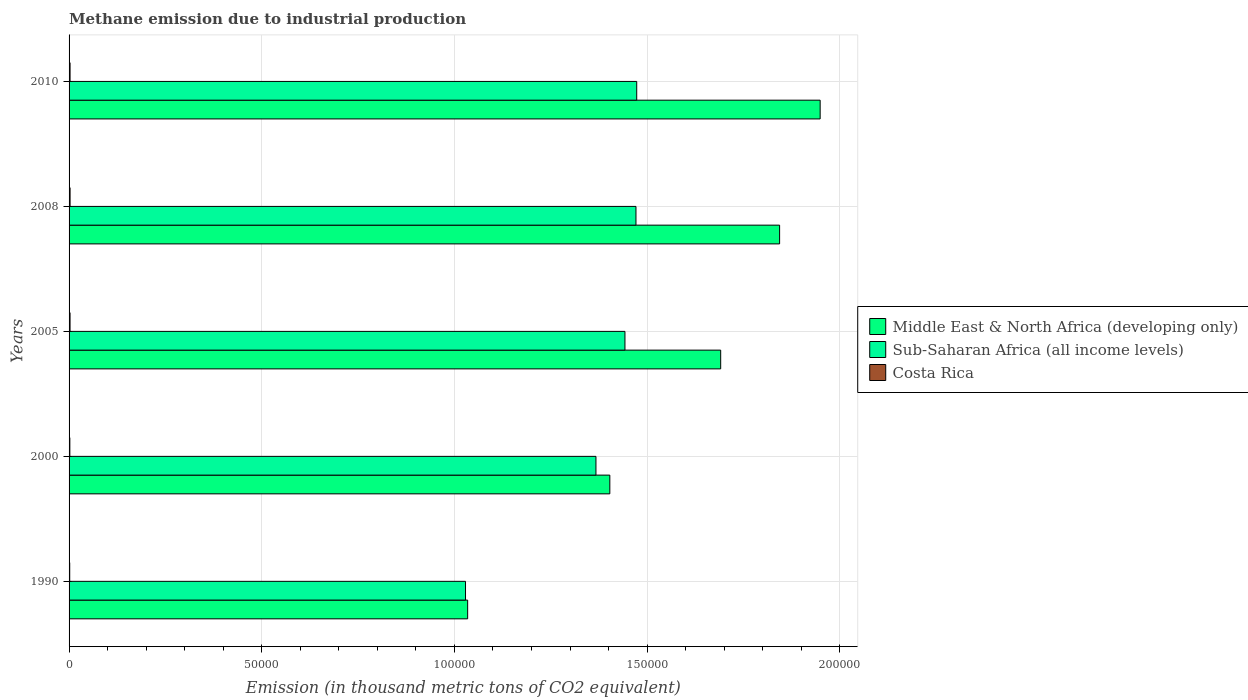How many different coloured bars are there?
Offer a very short reply. 3. Are the number of bars per tick equal to the number of legend labels?
Provide a succinct answer. Yes. Are the number of bars on each tick of the Y-axis equal?
Ensure brevity in your answer.  Yes. How many bars are there on the 2nd tick from the top?
Provide a short and direct response. 3. What is the label of the 1st group of bars from the top?
Give a very brief answer. 2010. In how many cases, is the number of bars for a given year not equal to the number of legend labels?
Your answer should be very brief. 0. What is the amount of methane emitted in Costa Rica in 2008?
Give a very brief answer. 261.8. Across all years, what is the maximum amount of methane emitted in Sub-Saharan Africa (all income levels)?
Offer a terse response. 1.47e+05. Across all years, what is the minimum amount of methane emitted in Sub-Saharan Africa (all income levels)?
Provide a short and direct response. 1.03e+05. In which year was the amount of methane emitted in Costa Rica maximum?
Your answer should be very brief. 2008. In which year was the amount of methane emitted in Middle East & North Africa (developing only) minimum?
Provide a succinct answer. 1990. What is the total amount of methane emitted in Sub-Saharan Africa (all income levels) in the graph?
Provide a succinct answer. 6.78e+05. What is the difference between the amount of methane emitted in Middle East & North Africa (developing only) in 2005 and that in 2010?
Your answer should be very brief. -2.58e+04. What is the difference between the amount of methane emitted in Costa Rica in 2010 and the amount of methane emitted in Middle East & North Africa (developing only) in 2000?
Your response must be concise. -1.40e+05. What is the average amount of methane emitted in Costa Rica per year?
Provide a short and direct response. 229.22. In the year 2008, what is the difference between the amount of methane emitted in Costa Rica and amount of methane emitted in Middle East & North Africa (developing only)?
Make the answer very short. -1.84e+05. In how many years, is the amount of methane emitted in Middle East & North Africa (developing only) greater than 80000 thousand metric tons?
Your answer should be compact. 5. What is the ratio of the amount of methane emitted in Sub-Saharan Africa (all income levels) in 1990 to that in 2005?
Provide a short and direct response. 0.71. Is the difference between the amount of methane emitted in Costa Rica in 1990 and 2010 greater than the difference between the amount of methane emitted in Middle East & North Africa (developing only) in 1990 and 2010?
Ensure brevity in your answer.  Yes. What is the difference between the highest and the second highest amount of methane emitted in Sub-Saharan Africa (all income levels)?
Provide a short and direct response. 192.3. What is the difference between the highest and the lowest amount of methane emitted in Costa Rica?
Offer a terse response. 93.6. In how many years, is the amount of methane emitted in Sub-Saharan Africa (all income levels) greater than the average amount of methane emitted in Sub-Saharan Africa (all income levels) taken over all years?
Offer a very short reply. 4. What does the 2nd bar from the top in 1990 represents?
Offer a terse response. Sub-Saharan Africa (all income levels). What is the difference between two consecutive major ticks on the X-axis?
Your answer should be compact. 5.00e+04. Are the values on the major ticks of X-axis written in scientific E-notation?
Make the answer very short. No. How are the legend labels stacked?
Provide a short and direct response. Vertical. What is the title of the graph?
Offer a terse response. Methane emission due to industrial production. What is the label or title of the X-axis?
Your answer should be very brief. Emission (in thousand metric tons of CO2 equivalent). What is the Emission (in thousand metric tons of CO2 equivalent) of Middle East & North Africa (developing only) in 1990?
Your answer should be compact. 1.03e+05. What is the Emission (in thousand metric tons of CO2 equivalent) in Sub-Saharan Africa (all income levels) in 1990?
Your response must be concise. 1.03e+05. What is the Emission (in thousand metric tons of CO2 equivalent) of Costa Rica in 1990?
Provide a short and direct response. 168.2. What is the Emission (in thousand metric tons of CO2 equivalent) of Middle East & North Africa (developing only) in 2000?
Your answer should be compact. 1.40e+05. What is the Emission (in thousand metric tons of CO2 equivalent) of Sub-Saharan Africa (all income levels) in 2000?
Provide a short and direct response. 1.37e+05. What is the Emission (in thousand metric tons of CO2 equivalent) in Costa Rica in 2000?
Your response must be concise. 202.3. What is the Emission (in thousand metric tons of CO2 equivalent) of Middle East & North Africa (developing only) in 2005?
Offer a terse response. 1.69e+05. What is the Emission (in thousand metric tons of CO2 equivalent) in Sub-Saharan Africa (all income levels) in 2005?
Offer a very short reply. 1.44e+05. What is the Emission (in thousand metric tons of CO2 equivalent) in Costa Rica in 2005?
Your response must be concise. 254.9. What is the Emission (in thousand metric tons of CO2 equivalent) in Middle East & North Africa (developing only) in 2008?
Offer a very short reply. 1.84e+05. What is the Emission (in thousand metric tons of CO2 equivalent) of Sub-Saharan Africa (all income levels) in 2008?
Keep it short and to the point. 1.47e+05. What is the Emission (in thousand metric tons of CO2 equivalent) of Costa Rica in 2008?
Ensure brevity in your answer.  261.8. What is the Emission (in thousand metric tons of CO2 equivalent) in Middle East & North Africa (developing only) in 2010?
Offer a very short reply. 1.95e+05. What is the Emission (in thousand metric tons of CO2 equivalent) in Sub-Saharan Africa (all income levels) in 2010?
Give a very brief answer. 1.47e+05. What is the Emission (in thousand metric tons of CO2 equivalent) in Costa Rica in 2010?
Offer a very short reply. 258.9. Across all years, what is the maximum Emission (in thousand metric tons of CO2 equivalent) in Middle East & North Africa (developing only)?
Your response must be concise. 1.95e+05. Across all years, what is the maximum Emission (in thousand metric tons of CO2 equivalent) in Sub-Saharan Africa (all income levels)?
Ensure brevity in your answer.  1.47e+05. Across all years, what is the maximum Emission (in thousand metric tons of CO2 equivalent) of Costa Rica?
Your answer should be very brief. 261.8. Across all years, what is the minimum Emission (in thousand metric tons of CO2 equivalent) of Middle East & North Africa (developing only)?
Provide a succinct answer. 1.03e+05. Across all years, what is the minimum Emission (in thousand metric tons of CO2 equivalent) of Sub-Saharan Africa (all income levels)?
Provide a short and direct response. 1.03e+05. Across all years, what is the minimum Emission (in thousand metric tons of CO2 equivalent) of Costa Rica?
Offer a very short reply. 168.2. What is the total Emission (in thousand metric tons of CO2 equivalent) of Middle East & North Africa (developing only) in the graph?
Provide a short and direct response. 7.92e+05. What is the total Emission (in thousand metric tons of CO2 equivalent) in Sub-Saharan Africa (all income levels) in the graph?
Your answer should be compact. 6.78e+05. What is the total Emission (in thousand metric tons of CO2 equivalent) in Costa Rica in the graph?
Your response must be concise. 1146.1. What is the difference between the Emission (in thousand metric tons of CO2 equivalent) of Middle East & North Africa (developing only) in 1990 and that in 2000?
Keep it short and to the point. -3.69e+04. What is the difference between the Emission (in thousand metric tons of CO2 equivalent) in Sub-Saharan Africa (all income levels) in 1990 and that in 2000?
Make the answer very short. -3.38e+04. What is the difference between the Emission (in thousand metric tons of CO2 equivalent) of Costa Rica in 1990 and that in 2000?
Provide a short and direct response. -34.1. What is the difference between the Emission (in thousand metric tons of CO2 equivalent) of Middle East & North Africa (developing only) in 1990 and that in 2005?
Ensure brevity in your answer.  -6.57e+04. What is the difference between the Emission (in thousand metric tons of CO2 equivalent) in Sub-Saharan Africa (all income levels) in 1990 and that in 2005?
Keep it short and to the point. -4.14e+04. What is the difference between the Emission (in thousand metric tons of CO2 equivalent) in Costa Rica in 1990 and that in 2005?
Make the answer very short. -86.7. What is the difference between the Emission (in thousand metric tons of CO2 equivalent) in Middle East & North Africa (developing only) in 1990 and that in 2008?
Offer a very short reply. -8.10e+04. What is the difference between the Emission (in thousand metric tons of CO2 equivalent) of Sub-Saharan Africa (all income levels) in 1990 and that in 2008?
Your answer should be very brief. -4.42e+04. What is the difference between the Emission (in thousand metric tons of CO2 equivalent) of Costa Rica in 1990 and that in 2008?
Provide a short and direct response. -93.6. What is the difference between the Emission (in thousand metric tons of CO2 equivalent) in Middle East & North Africa (developing only) in 1990 and that in 2010?
Make the answer very short. -9.15e+04. What is the difference between the Emission (in thousand metric tons of CO2 equivalent) of Sub-Saharan Africa (all income levels) in 1990 and that in 2010?
Make the answer very short. -4.44e+04. What is the difference between the Emission (in thousand metric tons of CO2 equivalent) of Costa Rica in 1990 and that in 2010?
Keep it short and to the point. -90.7. What is the difference between the Emission (in thousand metric tons of CO2 equivalent) of Middle East & North Africa (developing only) in 2000 and that in 2005?
Your answer should be compact. -2.88e+04. What is the difference between the Emission (in thousand metric tons of CO2 equivalent) of Sub-Saharan Africa (all income levels) in 2000 and that in 2005?
Keep it short and to the point. -7528.2. What is the difference between the Emission (in thousand metric tons of CO2 equivalent) of Costa Rica in 2000 and that in 2005?
Give a very brief answer. -52.6. What is the difference between the Emission (in thousand metric tons of CO2 equivalent) of Middle East & North Africa (developing only) in 2000 and that in 2008?
Make the answer very short. -4.41e+04. What is the difference between the Emission (in thousand metric tons of CO2 equivalent) in Sub-Saharan Africa (all income levels) in 2000 and that in 2008?
Make the answer very short. -1.04e+04. What is the difference between the Emission (in thousand metric tons of CO2 equivalent) in Costa Rica in 2000 and that in 2008?
Make the answer very short. -59.5. What is the difference between the Emission (in thousand metric tons of CO2 equivalent) of Middle East & North Africa (developing only) in 2000 and that in 2010?
Your response must be concise. -5.46e+04. What is the difference between the Emission (in thousand metric tons of CO2 equivalent) in Sub-Saharan Africa (all income levels) in 2000 and that in 2010?
Provide a short and direct response. -1.06e+04. What is the difference between the Emission (in thousand metric tons of CO2 equivalent) of Costa Rica in 2000 and that in 2010?
Your answer should be very brief. -56.6. What is the difference between the Emission (in thousand metric tons of CO2 equivalent) in Middle East & North Africa (developing only) in 2005 and that in 2008?
Your response must be concise. -1.53e+04. What is the difference between the Emission (in thousand metric tons of CO2 equivalent) of Sub-Saharan Africa (all income levels) in 2005 and that in 2008?
Your response must be concise. -2859.6. What is the difference between the Emission (in thousand metric tons of CO2 equivalent) in Costa Rica in 2005 and that in 2008?
Your answer should be very brief. -6.9. What is the difference between the Emission (in thousand metric tons of CO2 equivalent) in Middle East & North Africa (developing only) in 2005 and that in 2010?
Your response must be concise. -2.58e+04. What is the difference between the Emission (in thousand metric tons of CO2 equivalent) of Sub-Saharan Africa (all income levels) in 2005 and that in 2010?
Provide a short and direct response. -3051.9. What is the difference between the Emission (in thousand metric tons of CO2 equivalent) in Middle East & North Africa (developing only) in 2008 and that in 2010?
Ensure brevity in your answer.  -1.05e+04. What is the difference between the Emission (in thousand metric tons of CO2 equivalent) in Sub-Saharan Africa (all income levels) in 2008 and that in 2010?
Your answer should be very brief. -192.3. What is the difference between the Emission (in thousand metric tons of CO2 equivalent) in Costa Rica in 2008 and that in 2010?
Give a very brief answer. 2.9. What is the difference between the Emission (in thousand metric tons of CO2 equivalent) of Middle East & North Africa (developing only) in 1990 and the Emission (in thousand metric tons of CO2 equivalent) of Sub-Saharan Africa (all income levels) in 2000?
Your answer should be compact. -3.33e+04. What is the difference between the Emission (in thousand metric tons of CO2 equivalent) of Middle East & North Africa (developing only) in 1990 and the Emission (in thousand metric tons of CO2 equivalent) of Costa Rica in 2000?
Provide a short and direct response. 1.03e+05. What is the difference between the Emission (in thousand metric tons of CO2 equivalent) of Sub-Saharan Africa (all income levels) in 1990 and the Emission (in thousand metric tons of CO2 equivalent) of Costa Rica in 2000?
Offer a very short reply. 1.03e+05. What is the difference between the Emission (in thousand metric tons of CO2 equivalent) in Middle East & North Africa (developing only) in 1990 and the Emission (in thousand metric tons of CO2 equivalent) in Sub-Saharan Africa (all income levels) in 2005?
Your response must be concise. -4.08e+04. What is the difference between the Emission (in thousand metric tons of CO2 equivalent) in Middle East & North Africa (developing only) in 1990 and the Emission (in thousand metric tons of CO2 equivalent) in Costa Rica in 2005?
Your response must be concise. 1.03e+05. What is the difference between the Emission (in thousand metric tons of CO2 equivalent) in Sub-Saharan Africa (all income levels) in 1990 and the Emission (in thousand metric tons of CO2 equivalent) in Costa Rica in 2005?
Offer a very short reply. 1.03e+05. What is the difference between the Emission (in thousand metric tons of CO2 equivalent) of Middle East & North Africa (developing only) in 1990 and the Emission (in thousand metric tons of CO2 equivalent) of Sub-Saharan Africa (all income levels) in 2008?
Provide a short and direct response. -4.37e+04. What is the difference between the Emission (in thousand metric tons of CO2 equivalent) of Middle East & North Africa (developing only) in 1990 and the Emission (in thousand metric tons of CO2 equivalent) of Costa Rica in 2008?
Make the answer very short. 1.03e+05. What is the difference between the Emission (in thousand metric tons of CO2 equivalent) in Sub-Saharan Africa (all income levels) in 1990 and the Emission (in thousand metric tons of CO2 equivalent) in Costa Rica in 2008?
Offer a very short reply. 1.03e+05. What is the difference between the Emission (in thousand metric tons of CO2 equivalent) in Middle East & North Africa (developing only) in 1990 and the Emission (in thousand metric tons of CO2 equivalent) in Sub-Saharan Africa (all income levels) in 2010?
Keep it short and to the point. -4.39e+04. What is the difference between the Emission (in thousand metric tons of CO2 equivalent) in Middle East & North Africa (developing only) in 1990 and the Emission (in thousand metric tons of CO2 equivalent) in Costa Rica in 2010?
Give a very brief answer. 1.03e+05. What is the difference between the Emission (in thousand metric tons of CO2 equivalent) in Sub-Saharan Africa (all income levels) in 1990 and the Emission (in thousand metric tons of CO2 equivalent) in Costa Rica in 2010?
Your answer should be very brief. 1.03e+05. What is the difference between the Emission (in thousand metric tons of CO2 equivalent) in Middle East & North Africa (developing only) in 2000 and the Emission (in thousand metric tons of CO2 equivalent) in Sub-Saharan Africa (all income levels) in 2005?
Provide a short and direct response. -3924.8. What is the difference between the Emission (in thousand metric tons of CO2 equivalent) in Middle East & North Africa (developing only) in 2000 and the Emission (in thousand metric tons of CO2 equivalent) in Costa Rica in 2005?
Provide a short and direct response. 1.40e+05. What is the difference between the Emission (in thousand metric tons of CO2 equivalent) of Sub-Saharan Africa (all income levels) in 2000 and the Emission (in thousand metric tons of CO2 equivalent) of Costa Rica in 2005?
Offer a terse response. 1.36e+05. What is the difference between the Emission (in thousand metric tons of CO2 equivalent) of Middle East & North Africa (developing only) in 2000 and the Emission (in thousand metric tons of CO2 equivalent) of Sub-Saharan Africa (all income levels) in 2008?
Provide a succinct answer. -6784.4. What is the difference between the Emission (in thousand metric tons of CO2 equivalent) of Middle East & North Africa (developing only) in 2000 and the Emission (in thousand metric tons of CO2 equivalent) of Costa Rica in 2008?
Ensure brevity in your answer.  1.40e+05. What is the difference between the Emission (in thousand metric tons of CO2 equivalent) of Sub-Saharan Africa (all income levels) in 2000 and the Emission (in thousand metric tons of CO2 equivalent) of Costa Rica in 2008?
Make the answer very short. 1.36e+05. What is the difference between the Emission (in thousand metric tons of CO2 equivalent) of Middle East & North Africa (developing only) in 2000 and the Emission (in thousand metric tons of CO2 equivalent) of Sub-Saharan Africa (all income levels) in 2010?
Provide a short and direct response. -6976.7. What is the difference between the Emission (in thousand metric tons of CO2 equivalent) in Middle East & North Africa (developing only) in 2000 and the Emission (in thousand metric tons of CO2 equivalent) in Costa Rica in 2010?
Your answer should be compact. 1.40e+05. What is the difference between the Emission (in thousand metric tons of CO2 equivalent) in Sub-Saharan Africa (all income levels) in 2000 and the Emission (in thousand metric tons of CO2 equivalent) in Costa Rica in 2010?
Provide a short and direct response. 1.36e+05. What is the difference between the Emission (in thousand metric tons of CO2 equivalent) in Middle East & North Africa (developing only) in 2005 and the Emission (in thousand metric tons of CO2 equivalent) in Sub-Saharan Africa (all income levels) in 2008?
Give a very brief answer. 2.20e+04. What is the difference between the Emission (in thousand metric tons of CO2 equivalent) of Middle East & North Africa (developing only) in 2005 and the Emission (in thousand metric tons of CO2 equivalent) of Costa Rica in 2008?
Your answer should be compact. 1.69e+05. What is the difference between the Emission (in thousand metric tons of CO2 equivalent) in Sub-Saharan Africa (all income levels) in 2005 and the Emission (in thousand metric tons of CO2 equivalent) in Costa Rica in 2008?
Offer a very short reply. 1.44e+05. What is the difference between the Emission (in thousand metric tons of CO2 equivalent) in Middle East & North Africa (developing only) in 2005 and the Emission (in thousand metric tons of CO2 equivalent) in Sub-Saharan Africa (all income levels) in 2010?
Your response must be concise. 2.18e+04. What is the difference between the Emission (in thousand metric tons of CO2 equivalent) of Middle East & North Africa (developing only) in 2005 and the Emission (in thousand metric tons of CO2 equivalent) of Costa Rica in 2010?
Your answer should be compact. 1.69e+05. What is the difference between the Emission (in thousand metric tons of CO2 equivalent) in Sub-Saharan Africa (all income levels) in 2005 and the Emission (in thousand metric tons of CO2 equivalent) in Costa Rica in 2010?
Ensure brevity in your answer.  1.44e+05. What is the difference between the Emission (in thousand metric tons of CO2 equivalent) in Middle East & North Africa (developing only) in 2008 and the Emission (in thousand metric tons of CO2 equivalent) in Sub-Saharan Africa (all income levels) in 2010?
Make the answer very short. 3.71e+04. What is the difference between the Emission (in thousand metric tons of CO2 equivalent) in Middle East & North Africa (developing only) in 2008 and the Emission (in thousand metric tons of CO2 equivalent) in Costa Rica in 2010?
Offer a terse response. 1.84e+05. What is the difference between the Emission (in thousand metric tons of CO2 equivalent) in Sub-Saharan Africa (all income levels) in 2008 and the Emission (in thousand metric tons of CO2 equivalent) in Costa Rica in 2010?
Make the answer very short. 1.47e+05. What is the average Emission (in thousand metric tons of CO2 equivalent) in Middle East & North Africa (developing only) per year?
Make the answer very short. 1.58e+05. What is the average Emission (in thousand metric tons of CO2 equivalent) of Sub-Saharan Africa (all income levels) per year?
Ensure brevity in your answer.  1.36e+05. What is the average Emission (in thousand metric tons of CO2 equivalent) in Costa Rica per year?
Provide a short and direct response. 229.22. In the year 1990, what is the difference between the Emission (in thousand metric tons of CO2 equivalent) in Middle East & North Africa (developing only) and Emission (in thousand metric tons of CO2 equivalent) in Sub-Saharan Africa (all income levels)?
Offer a very short reply. 552.6. In the year 1990, what is the difference between the Emission (in thousand metric tons of CO2 equivalent) in Middle East & North Africa (developing only) and Emission (in thousand metric tons of CO2 equivalent) in Costa Rica?
Provide a succinct answer. 1.03e+05. In the year 1990, what is the difference between the Emission (in thousand metric tons of CO2 equivalent) in Sub-Saharan Africa (all income levels) and Emission (in thousand metric tons of CO2 equivalent) in Costa Rica?
Ensure brevity in your answer.  1.03e+05. In the year 2000, what is the difference between the Emission (in thousand metric tons of CO2 equivalent) in Middle East & North Africa (developing only) and Emission (in thousand metric tons of CO2 equivalent) in Sub-Saharan Africa (all income levels)?
Make the answer very short. 3603.4. In the year 2000, what is the difference between the Emission (in thousand metric tons of CO2 equivalent) in Middle East & North Africa (developing only) and Emission (in thousand metric tons of CO2 equivalent) in Costa Rica?
Your response must be concise. 1.40e+05. In the year 2000, what is the difference between the Emission (in thousand metric tons of CO2 equivalent) in Sub-Saharan Africa (all income levels) and Emission (in thousand metric tons of CO2 equivalent) in Costa Rica?
Your response must be concise. 1.37e+05. In the year 2005, what is the difference between the Emission (in thousand metric tons of CO2 equivalent) of Middle East & North Africa (developing only) and Emission (in thousand metric tons of CO2 equivalent) of Sub-Saharan Africa (all income levels)?
Offer a terse response. 2.48e+04. In the year 2005, what is the difference between the Emission (in thousand metric tons of CO2 equivalent) of Middle East & North Africa (developing only) and Emission (in thousand metric tons of CO2 equivalent) of Costa Rica?
Make the answer very short. 1.69e+05. In the year 2005, what is the difference between the Emission (in thousand metric tons of CO2 equivalent) of Sub-Saharan Africa (all income levels) and Emission (in thousand metric tons of CO2 equivalent) of Costa Rica?
Offer a very short reply. 1.44e+05. In the year 2008, what is the difference between the Emission (in thousand metric tons of CO2 equivalent) of Middle East & North Africa (developing only) and Emission (in thousand metric tons of CO2 equivalent) of Sub-Saharan Africa (all income levels)?
Ensure brevity in your answer.  3.73e+04. In the year 2008, what is the difference between the Emission (in thousand metric tons of CO2 equivalent) in Middle East & North Africa (developing only) and Emission (in thousand metric tons of CO2 equivalent) in Costa Rica?
Provide a short and direct response. 1.84e+05. In the year 2008, what is the difference between the Emission (in thousand metric tons of CO2 equivalent) of Sub-Saharan Africa (all income levels) and Emission (in thousand metric tons of CO2 equivalent) of Costa Rica?
Offer a very short reply. 1.47e+05. In the year 2010, what is the difference between the Emission (in thousand metric tons of CO2 equivalent) of Middle East & North Africa (developing only) and Emission (in thousand metric tons of CO2 equivalent) of Sub-Saharan Africa (all income levels)?
Provide a succinct answer. 4.76e+04. In the year 2010, what is the difference between the Emission (in thousand metric tons of CO2 equivalent) in Middle East & North Africa (developing only) and Emission (in thousand metric tons of CO2 equivalent) in Costa Rica?
Provide a succinct answer. 1.95e+05. In the year 2010, what is the difference between the Emission (in thousand metric tons of CO2 equivalent) in Sub-Saharan Africa (all income levels) and Emission (in thousand metric tons of CO2 equivalent) in Costa Rica?
Keep it short and to the point. 1.47e+05. What is the ratio of the Emission (in thousand metric tons of CO2 equivalent) in Middle East & North Africa (developing only) in 1990 to that in 2000?
Your answer should be very brief. 0.74. What is the ratio of the Emission (in thousand metric tons of CO2 equivalent) in Sub-Saharan Africa (all income levels) in 1990 to that in 2000?
Give a very brief answer. 0.75. What is the ratio of the Emission (in thousand metric tons of CO2 equivalent) of Costa Rica in 1990 to that in 2000?
Your answer should be very brief. 0.83. What is the ratio of the Emission (in thousand metric tons of CO2 equivalent) in Middle East & North Africa (developing only) in 1990 to that in 2005?
Provide a short and direct response. 0.61. What is the ratio of the Emission (in thousand metric tons of CO2 equivalent) in Sub-Saharan Africa (all income levels) in 1990 to that in 2005?
Your answer should be compact. 0.71. What is the ratio of the Emission (in thousand metric tons of CO2 equivalent) in Costa Rica in 1990 to that in 2005?
Your response must be concise. 0.66. What is the ratio of the Emission (in thousand metric tons of CO2 equivalent) in Middle East & North Africa (developing only) in 1990 to that in 2008?
Offer a terse response. 0.56. What is the ratio of the Emission (in thousand metric tons of CO2 equivalent) in Sub-Saharan Africa (all income levels) in 1990 to that in 2008?
Offer a terse response. 0.7. What is the ratio of the Emission (in thousand metric tons of CO2 equivalent) of Costa Rica in 1990 to that in 2008?
Offer a very short reply. 0.64. What is the ratio of the Emission (in thousand metric tons of CO2 equivalent) of Middle East & North Africa (developing only) in 1990 to that in 2010?
Provide a short and direct response. 0.53. What is the ratio of the Emission (in thousand metric tons of CO2 equivalent) in Sub-Saharan Africa (all income levels) in 1990 to that in 2010?
Your answer should be compact. 0.7. What is the ratio of the Emission (in thousand metric tons of CO2 equivalent) of Costa Rica in 1990 to that in 2010?
Your answer should be compact. 0.65. What is the ratio of the Emission (in thousand metric tons of CO2 equivalent) of Middle East & North Africa (developing only) in 2000 to that in 2005?
Make the answer very short. 0.83. What is the ratio of the Emission (in thousand metric tons of CO2 equivalent) in Sub-Saharan Africa (all income levels) in 2000 to that in 2005?
Your answer should be compact. 0.95. What is the ratio of the Emission (in thousand metric tons of CO2 equivalent) of Costa Rica in 2000 to that in 2005?
Your answer should be compact. 0.79. What is the ratio of the Emission (in thousand metric tons of CO2 equivalent) in Middle East & North Africa (developing only) in 2000 to that in 2008?
Provide a short and direct response. 0.76. What is the ratio of the Emission (in thousand metric tons of CO2 equivalent) in Sub-Saharan Africa (all income levels) in 2000 to that in 2008?
Give a very brief answer. 0.93. What is the ratio of the Emission (in thousand metric tons of CO2 equivalent) of Costa Rica in 2000 to that in 2008?
Provide a succinct answer. 0.77. What is the ratio of the Emission (in thousand metric tons of CO2 equivalent) in Middle East & North Africa (developing only) in 2000 to that in 2010?
Give a very brief answer. 0.72. What is the ratio of the Emission (in thousand metric tons of CO2 equivalent) in Sub-Saharan Africa (all income levels) in 2000 to that in 2010?
Make the answer very short. 0.93. What is the ratio of the Emission (in thousand metric tons of CO2 equivalent) in Costa Rica in 2000 to that in 2010?
Provide a short and direct response. 0.78. What is the ratio of the Emission (in thousand metric tons of CO2 equivalent) of Middle East & North Africa (developing only) in 2005 to that in 2008?
Keep it short and to the point. 0.92. What is the ratio of the Emission (in thousand metric tons of CO2 equivalent) of Sub-Saharan Africa (all income levels) in 2005 to that in 2008?
Your answer should be very brief. 0.98. What is the ratio of the Emission (in thousand metric tons of CO2 equivalent) of Costa Rica in 2005 to that in 2008?
Your answer should be very brief. 0.97. What is the ratio of the Emission (in thousand metric tons of CO2 equivalent) of Middle East & North Africa (developing only) in 2005 to that in 2010?
Ensure brevity in your answer.  0.87. What is the ratio of the Emission (in thousand metric tons of CO2 equivalent) of Sub-Saharan Africa (all income levels) in 2005 to that in 2010?
Offer a very short reply. 0.98. What is the ratio of the Emission (in thousand metric tons of CO2 equivalent) in Costa Rica in 2005 to that in 2010?
Make the answer very short. 0.98. What is the ratio of the Emission (in thousand metric tons of CO2 equivalent) in Middle East & North Africa (developing only) in 2008 to that in 2010?
Your answer should be very brief. 0.95. What is the ratio of the Emission (in thousand metric tons of CO2 equivalent) of Sub-Saharan Africa (all income levels) in 2008 to that in 2010?
Keep it short and to the point. 1. What is the ratio of the Emission (in thousand metric tons of CO2 equivalent) of Costa Rica in 2008 to that in 2010?
Keep it short and to the point. 1.01. What is the difference between the highest and the second highest Emission (in thousand metric tons of CO2 equivalent) in Middle East & North Africa (developing only)?
Give a very brief answer. 1.05e+04. What is the difference between the highest and the second highest Emission (in thousand metric tons of CO2 equivalent) of Sub-Saharan Africa (all income levels)?
Keep it short and to the point. 192.3. What is the difference between the highest and the second highest Emission (in thousand metric tons of CO2 equivalent) in Costa Rica?
Provide a short and direct response. 2.9. What is the difference between the highest and the lowest Emission (in thousand metric tons of CO2 equivalent) in Middle East & North Africa (developing only)?
Provide a short and direct response. 9.15e+04. What is the difference between the highest and the lowest Emission (in thousand metric tons of CO2 equivalent) of Sub-Saharan Africa (all income levels)?
Your answer should be compact. 4.44e+04. What is the difference between the highest and the lowest Emission (in thousand metric tons of CO2 equivalent) in Costa Rica?
Your answer should be compact. 93.6. 